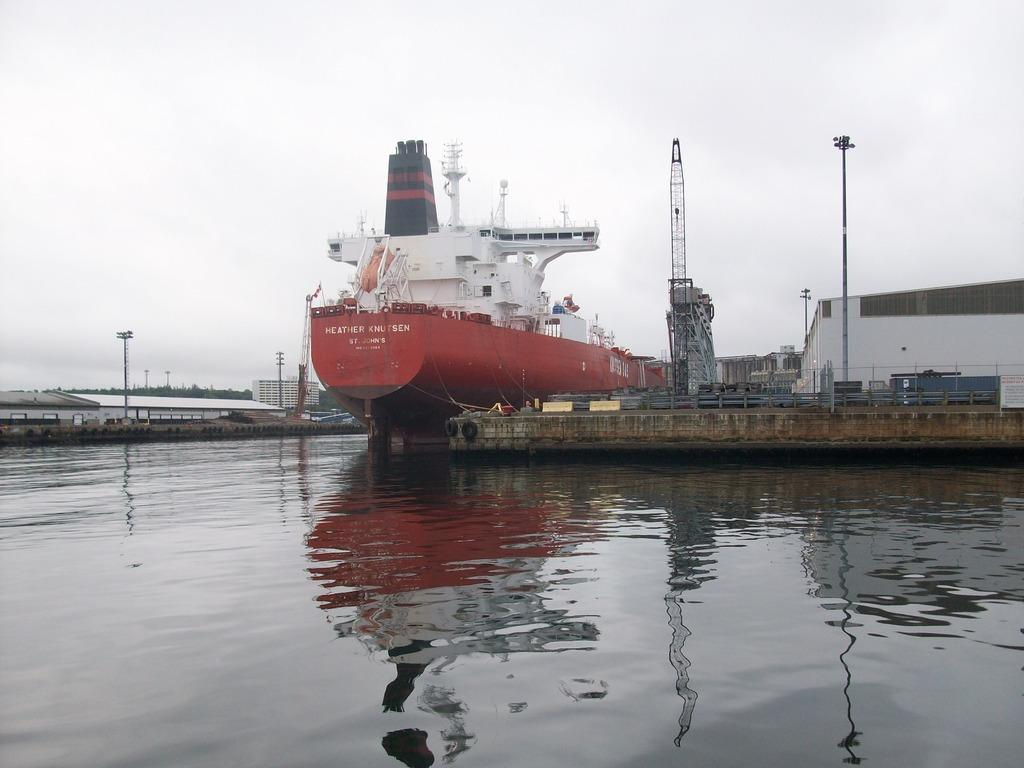<image>
Present a compact description of the photo's key features. the name Heather is on the front of the boat 